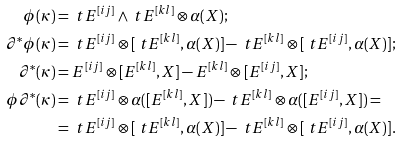Convert formula to latex. <formula><loc_0><loc_0><loc_500><loc_500>\phi ( \kappa ) & = \ t E ^ { [ i j ] } \wedge \ t E ^ { [ k l ] } \otimes \alpha ( X ) ; \\ \partial ^ { * } \phi ( \kappa ) & = \ t E ^ { [ i j ] } \otimes [ \ t E ^ { [ k l ] } , \alpha ( X ) ] - \ t E ^ { [ k l ] } \otimes [ \ t E ^ { [ i j ] } , \alpha ( X ) ] ; \\ \partial ^ { * } ( \kappa ) & = E ^ { [ i j ] } \otimes [ E ^ { [ k l ] } , X ] - E ^ { [ k l ] } \otimes [ E ^ { [ i j ] } , X ] ; \\ \phi \partial ^ { * } ( \kappa ) & = \ t E ^ { [ i j ] } \otimes \alpha ( [ E ^ { [ k l ] } , X ] ) - \ t E ^ { [ k l ] } \otimes \alpha ( [ E ^ { [ i j ] } , X ] ) = \\ & = \ t E ^ { [ i j ] } \otimes [ \ t E ^ { [ k l ] } , \alpha ( X ) ] - \ t E ^ { [ k l ] } \otimes [ \ t E ^ { [ i j ] } , \alpha ( X ) ] .</formula> 